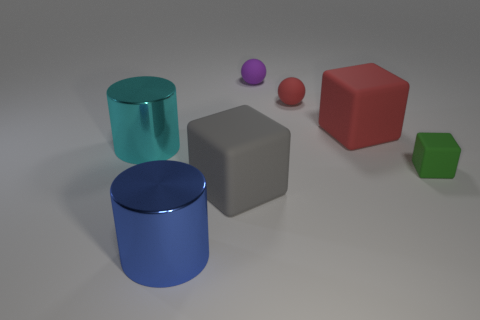Subtract all big red matte blocks. How many blocks are left? 2 Add 1 blue metal objects. How many objects exist? 8 Subtract all red spheres. How many spheres are left? 1 Subtract all blocks. How many objects are left? 4 Subtract all green matte cylinders. Subtract all tiny red balls. How many objects are left? 6 Add 6 cyan objects. How many cyan objects are left? 7 Add 3 small brown cubes. How many small brown cubes exist? 3 Subtract 1 purple balls. How many objects are left? 6 Subtract all red cubes. Subtract all red spheres. How many cubes are left? 2 